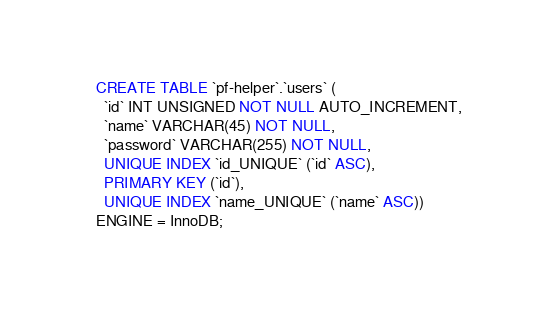<code> <loc_0><loc_0><loc_500><loc_500><_SQL_>CREATE TABLE `pf-helper`.`users` (
  `id` INT UNSIGNED NOT NULL AUTO_INCREMENT,
  `name` VARCHAR(45) NOT NULL,
  `password` VARCHAR(255) NOT NULL,
  UNIQUE INDEX `id_UNIQUE` (`id` ASC),
  PRIMARY KEY (`id`),
  UNIQUE INDEX `name_UNIQUE` (`name` ASC))
ENGINE = InnoDB;
</code> 